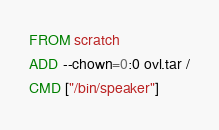<code> <loc_0><loc_0><loc_500><loc_500><_Dockerfile_>FROM scratch
ADD --chown=0:0 ovl.tar /
CMD ["/bin/speaker"]
</code> 